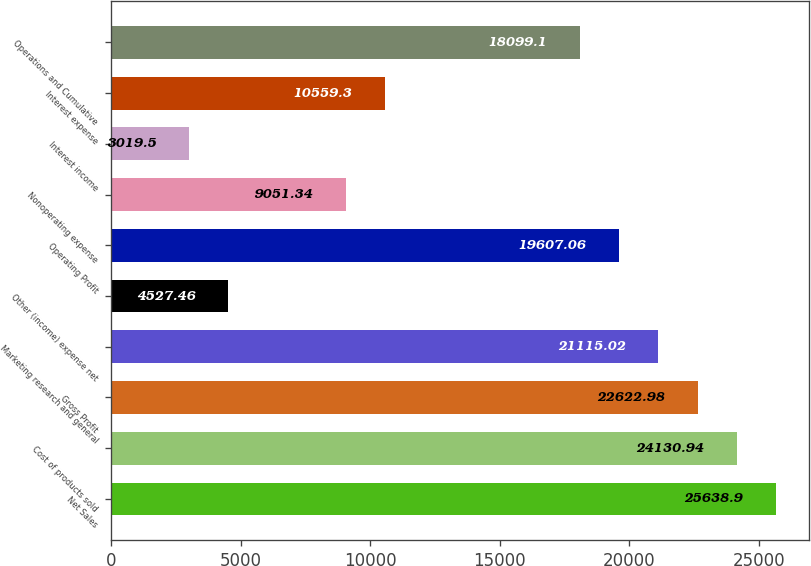<chart> <loc_0><loc_0><loc_500><loc_500><bar_chart><fcel>Net Sales<fcel>Cost of products sold<fcel>Gross Profit<fcel>Marketing research and general<fcel>Other (income) expense net<fcel>Operating Profit<fcel>Nonoperating expense<fcel>Interest income<fcel>Interest expense<fcel>Operations and Cumulative<nl><fcel>25638.9<fcel>24130.9<fcel>22623<fcel>21115<fcel>4527.46<fcel>19607.1<fcel>9051.34<fcel>3019.5<fcel>10559.3<fcel>18099.1<nl></chart> 